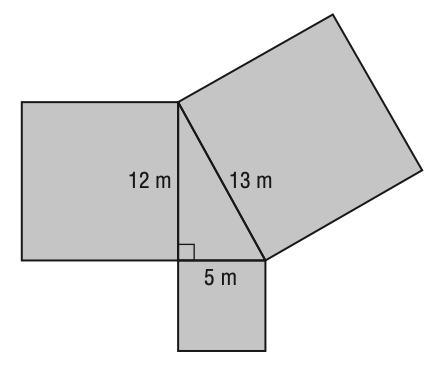Answer the mathemtical geometry problem and directly provide the correct option letter.
Question: What is the total area of the figure?
Choices: A: 30 B: 184 C: 338 D: 368 D 